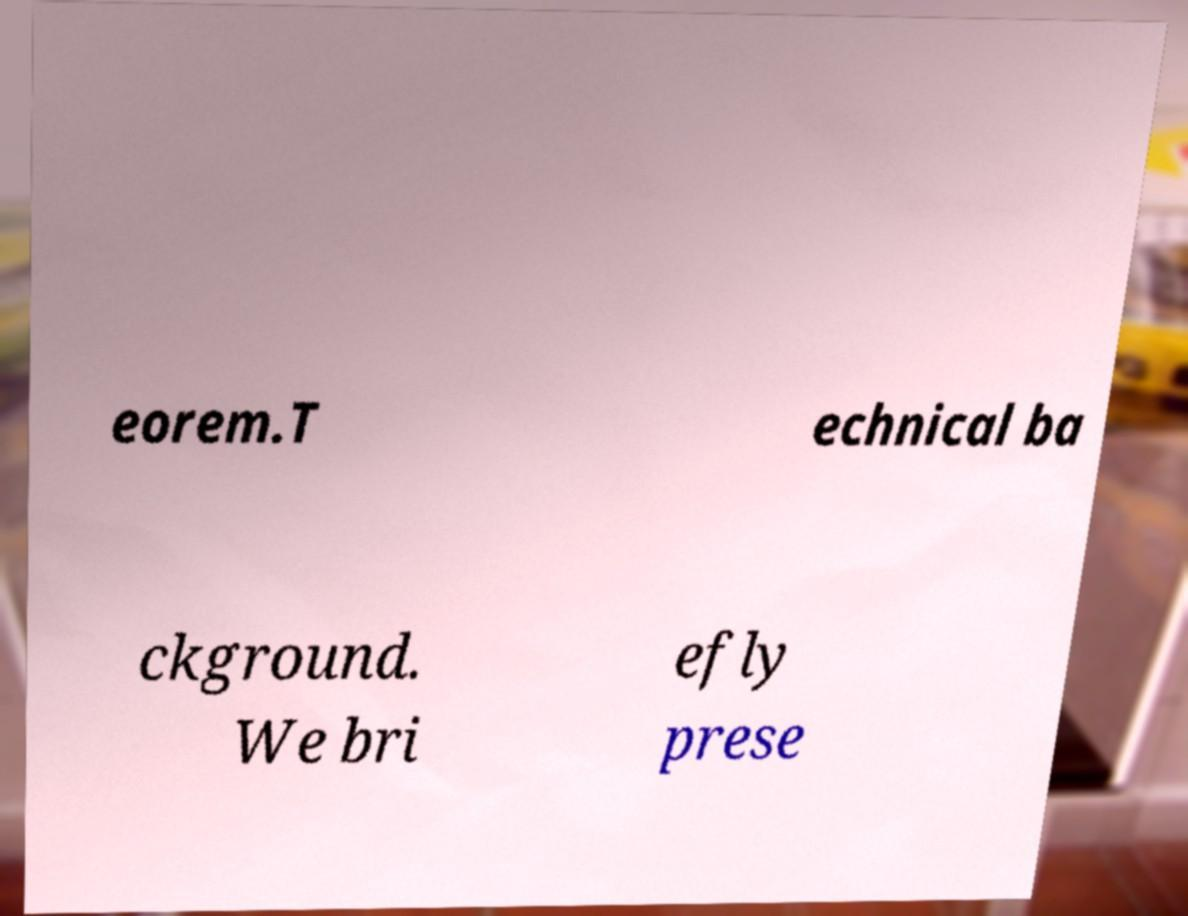For documentation purposes, I need the text within this image transcribed. Could you provide that? eorem.T echnical ba ckground. We bri efly prese 